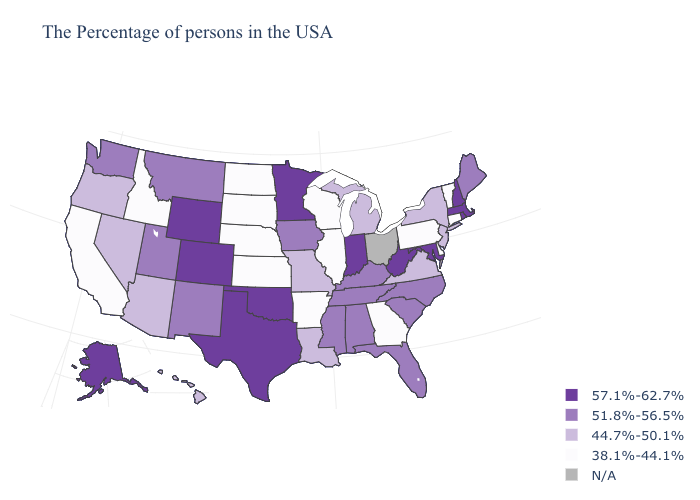How many symbols are there in the legend?
Give a very brief answer. 5. What is the value of Delaware?
Keep it brief. 38.1%-44.1%. Name the states that have a value in the range 57.1%-62.7%?
Be succinct. Massachusetts, Rhode Island, New Hampshire, Maryland, West Virginia, Indiana, Minnesota, Oklahoma, Texas, Wyoming, Colorado, Alaska. What is the highest value in states that border Wisconsin?
Give a very brief answer. 57.1%-62.7%. What is the highest value in the West ?
Quick response, please. 57.1%-62.7%. Which states have the lowest value in the USA?
Quick response, please. Vermont, Connecticut, Delaware, Pennsylvania, Georgia, Wisconsin, Illinois, Arkansas, Kansas, Nebraska, South Dakota, North Dakota, Idaho, California. Among the states that border Connecticut , which have the lowest value?
Be succinct. New York. How many symbols are there in the legend?
Keep it brief. 5. How many symbols are there in the legend?
Write a very short answer. 5. What is the value of Iowa?
Keep it brief. 51.8%-56.5%. Among the states that border West Virginia , which have the lowest value?
Short answer required. Pennsylvania. Among the states that border Idaho , which have the lowest value?
Be succinct. Nevada, Oregon. Name the states that have a value in the range 44.7%-50.1%?
Quick response, please. New York, New Jersey, Virginia, Michigan, Louisiana, Missouri, Arizona, Nevada, Oregon, Hawaii. Does the first symbol in the legend represent the smallest category?
Be succinct. No. Does Michigan have the lowest value in the MidWest?
Concise answer only. No. 